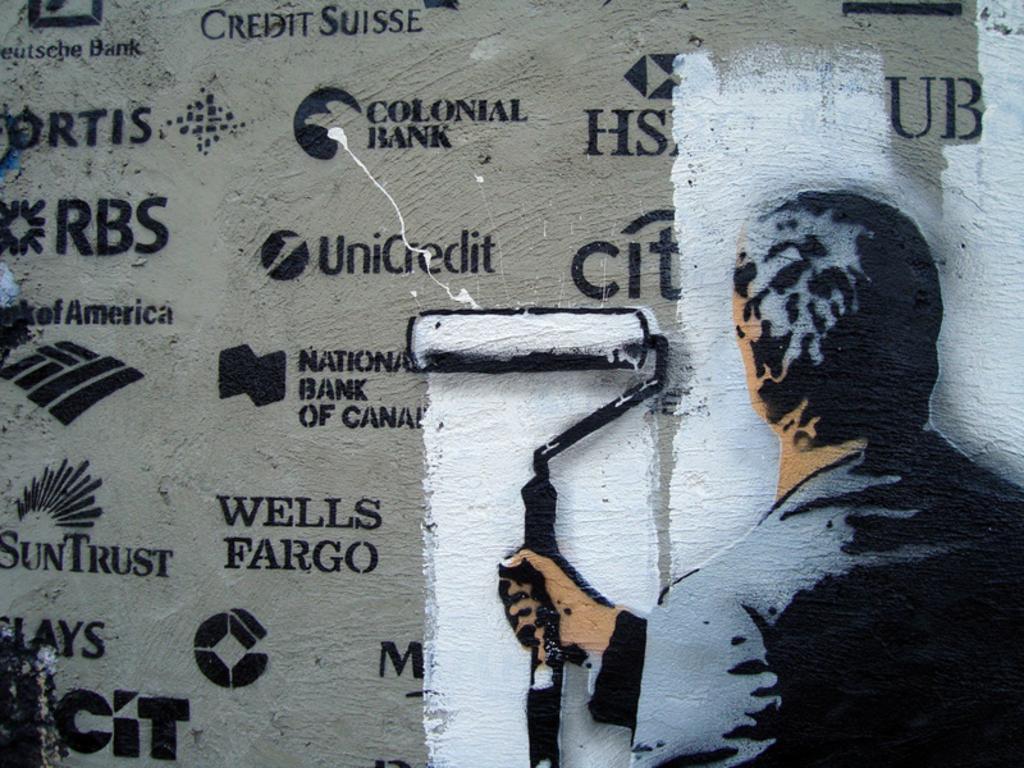What bank is towards the bottom of the ad?
Your response must be concise. Wells fargo. What is the second bank from the bottom left?
Offer a terse response. Suntrust. 